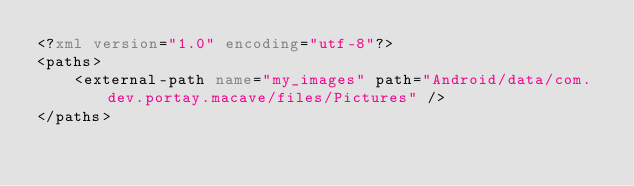<code> <loc_0><loc_0><loc_500><loc_500><_XML_><?xml version="1.0" encoding="utf-8"?>
<paths>
    <external-path name="my_images" path="Android/data/com.dev.portay.macave/files/Pictures" />
</paths></code> 